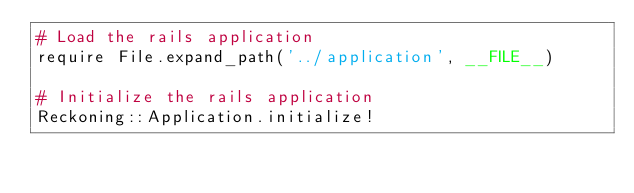Convert code to text. <code><loc_0><loc_0><loc_500><loc_500><_Ruby_># Load the rails application
require File.expand_path('../application', __FILE__)

# Initialize the rails application
Reckoning::Application.initialize!
</code> 